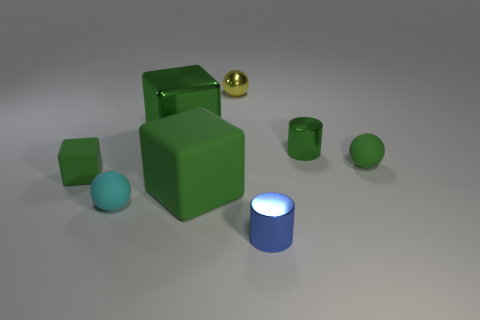Add 2 cylinders. How many objects exist? 10 Subtract all spheres. How many objects are left? 5 Add 1 yellow things. How many yellow things exist? 2 Subtract 0 brown cylinders. How many objects are left? 8 Subtract all large matte blocks. Subtract all small yellow things. How many objects are left? 6 Add 2 tiny blue metallic objects. How many tiny blue metallic objects are left? 3 